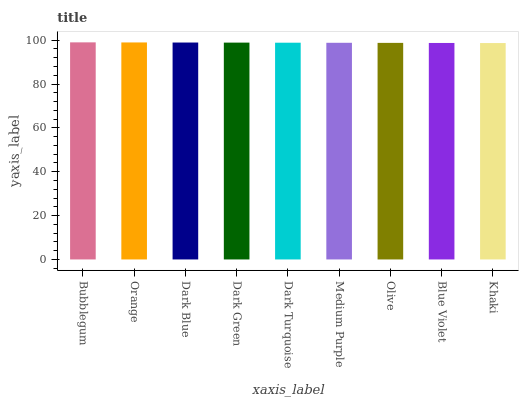Is Khaki the minimum?
Answer yes or no. Yes. Is Bubblegum the maximum?
Answer yes or no. Yes. Is Orange the minimum?
Answer yes or no. No. Is Orange the maximum?
Answer yes or no. No. Is Bubblegum greater than Orange?
Answer yes or no. Yes. Is Orange less than Bubblegum?
Answer yes or no. Yes. Is Orange greater than Bubblegum?
Answer yes or no. No. Is Bubblegum less than Orange?
Answer yes or no. No. Is Dark Turquoise the high median?
Answer yes or no. Yes. Is Dark Turquoise the low median?
Answer yes or no. Yes. Is Blue Violet the high median?
Answer yes or no. No. Is Khaki the low median?
Answer yes or no. No. 